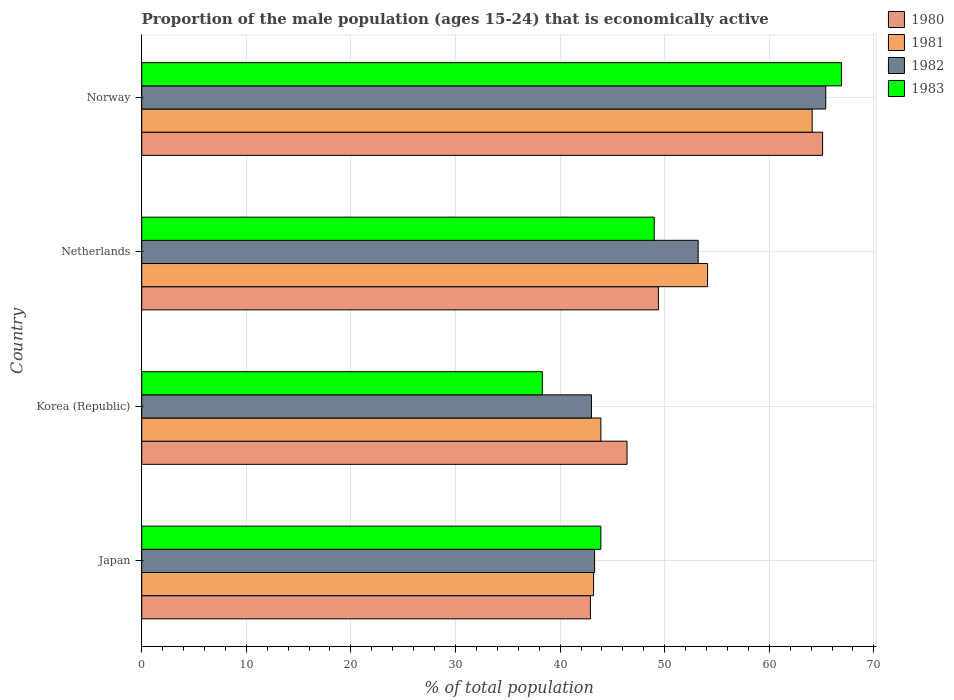How many different coloured bars are there?
Give a very brief answer. 4. How many groups of bars are there?
Give a very brief answer. 4. Are the number of bars on each tick of the Y-axis equal?
Ensure brevity in your answer.  Yes. How many bars are there on the 2nd tick from the top?
Ensure brevity in your answer.  4. What is the label of the 2nd group of bars from the top?
Your answer should be compact. Netherlands. In how many cases, is the number of bars for a given country not equal to the number of legend labels?
Offer a very short reply. 0. What is the proportion of the male population that is economically active in 1982 in Norway?
Your answer should be compact. 65.4. Across all countries, what is the maximum proportion of the male population that is economically active in 1981?
Provide a succinct answer. 64.1. Across all countries, what is the minimum proportion of the male population that is economically active in 1983?
Offer a very short reply. 38.3. In which country was the proportion of the male population that is economically active in 1981 maximum?
Your answer should be compact. Norway. In which country was the proportion of the male population that is economically active in 1982 minimum?
Give a very brief answer. Korea (Republic). What is the total proportion of the male population that is economically active in 1982 in the graph?
Offer a terse response. 204.9. What is the difference between the proportion of the male population that is economically active in 1982 in Netherlands and that in Norway?
Make the answer very short. -12.2. What is the difference between the proportion of the male population that is economically active in 1983 in Japan and the proportion of the male population that is economically active in 1980 in Norway?
Offer a terse response. -21.2. What is the average proportion of the male population that is economically active in 1982 per country?
Your answer should be very brief. 51.23. What is the difference between the proportion of the male population that is economically active in 1981 and proportion of the male population that is economically active in 1980 in Japan?
Offer a terse response. 0.3. What is the ratio of the proportion of the male population that is economically active in 1981 in Japan to that in Norway?
Provide a short and direct response. 0.67. What is the difference between the highest and the second highest proportion of the male population that is economically active in 1981?
Provide a short and direct response. 10. What is the difference between the highest and the lowest proportion of the male population that is economically active in 1981?
Offer a terse response. 20.9. Is the sum of the proportion of the male population that is economically active in 1980 in Japan and Korea (Republic) greater than the maximum proportion of the male population that is economically active in 1983 across all countries?
Give a very brief answer. Yes. What does the 1st bar from the bottom in Norway represents?
Your answer should be very brief. 1980. Is it the case that in every country, the sum of the proportion of the male population that is economically active in 1980 and proportion of the male population that is economically active in 1982 is greater than the proportion of the male population that is economically active in 1981?
Provide a short and direct response. Yes. Are all the bars in the graph horizontal?
Offer a terse response. Yes. Does the graph contain grids?
Your response must be concise. Yes. Where does the legend appear in the graph?
Keep it short and to the point. Top right. How many legend labels are there?
Offer a terse response. 4. How are the legend labels stacked?
Provide a succinct answer. Vertical. What is the title of the graph?
Make the answer very short. Proportion of the male population (ages 15-24) that is economically active. Does "2004" appear as one of the legend labels in the graph?
Provide a short and direct response. No. What is the label or title of the X-axis?
Keep it short and to the point. % of total population. What is the % of total population in 1980 in Japan?
Offer a very short reply. 42.9. What is the % of total population of 1981 in Japan?
Give a very brief answer. 43.2. What is the % of total population of 1982 in Japan?
Provide a succinct answer. 43.3. What is the % of total population in 1983 in Japan?
Provide a succinct answer. 43.9. What is the % of total population in 1980 in Korea (Republic)?
Your answer should be compact. 46.4. What is the % of total population of 1981 in Korea (Republic)?
Offer a very short reply. 43.9. What is the % of total population in 1982 in Korea (Republic)?
Provide a short and direct response. 43. What is the % of total population of 1983 in Korea (Republic)?
Make the answer very short. 38.3. What is the % of total population of 1980 in Netherlands?
Make the answer very short. 49.4. What is the % of total population in 1981 in Netherlands?
Offer a very short reply. 54.1. What is the % of total population in 1982 in Netherlands?
Provide a succinct answer. 53.2. What is the % of total population of 1980 in Norway?
Your response must be concise. 65.1. What is the % of total population of 1981 in Norway?
Make the answer very short. 64.1. What is the % of total population of 1982 in Norway?
Offer a terse response. 65.4. What is the % of total population in 1983 in Norway?
Your answer should be very brief. 66.9. Across all countries, what is the maximum % of total population in 1980?
Keep it short and to the point. 65.1. Across all countries, what is the maximum % of total population in 1981?
Make the answer very short. 64.1. Across all countries, what is the maximum % of total population of 1982?
Offer a terse response. 65.4. Across all countries, what is the maximum % of total population of 1983?
Provide a succinct answer. 66.9. Across all countries, what is the minimum % of total population in 1980?
Offer a terse response. 42.9. Across all countries, what is the minimum % of total population of 1981?
Make the answer very short. 43.2. Across all countries, what is the minimum % of total population in 1983?
Ensure brevity in your answer.  38.3. What is the total % of total population in 1980 in the graph?
Your answer should be compact. 203.8. What is the total % of total population of 1981 in the graph?
Your answer should be compact. 205.3. What is the total % of total population in 1982 in the graph?
Provide a succinct answer. 204.9. What is the total % of total population in 1983 in the graph?
Offer a terse response. 198.1. What is the difference between the % of total population of 1981 in Japan and that in Netherlands?
Make the answer very short. -10.9. What is the difference between the % of total population in 1980 in Japan and that in Norway?
Ensure brevity in your answer.  -22.2. What is the difference between the % of total population of 1981 in Japan and that in Norway?
Your answer should be very brief. -20.9. What is the difference between the % of total population in 1982 in Japan and that in Norway?
Provide a short and direct response. -22.1. What is the difference between the % of total population in 1981 in Korea (Republic) and that in Netherlands?
Provide a short and direct response. -10.2. What is the difference between the % of total population of 1982 in Korea (Republic) and that in Netherlands?
Your answer should be compact. -10.2. What is the difference between the % of total population in 1983 in Korea (Republic) and that in Netherlands?
Offer a very short reply. -10.7. What is the difference between the % of total population of 1980 in Korea (Republic) and that in Norway?
Offer a very short reply. -18.7. What is the difference between the % of total population in 1981 in Korea (Republic) and that in Norway?
Your answer should be very brief. -20.2. What is the difference between the % of total population of 1982 in Korea (Republic) and that in Norway?
Your answer should be compact. -22.4. What is the difference between the % of total population in 1983 in Korea (Republic) and that in Norway?
Offer a terse response. -28.6. What is the difference between the % of total population of 1980 in Netherlands and that in Norway?
Give a very brief answer. -15.7. What is the difference between the % of total population in 1981 in Netherlands and that in Norway?
Offer a terse response. -10. What is the difference between the % of total population in 1983 in Netherlands and that in Norway?
Your answer should be very brief. -17.9. What is the difference between the % of total population in 1980 in Japan and the % of total population in 1981 in Korea (Republic)?
Offer a terse response. -1. What is the difference between the % of total population of 1980 in Japan and the % of total population of 1982 in Korea (Republic)?
Provide a succinct answer. -0.1. What is the difference between the % of total population of 1981 in Japan and the % of total population of 1983 in Korea (Republic)?
Ensure brevity in your answer.  4.9. What is the difference between the % of total population of 1980 in Japan and the % of total population of 1983 in Netherlands?
Provide a succinct answer. -6.1. What is the difference between the % of total population of 1981 in Japan and the % of total population of 1982 in Netherlands?
Make the answer very short. -10. What is the difference between the % of total population of 1981 in Japan and the % of total population of 1983 in Netherlands?
Offer a very short reply. -5.8. What is the difference between the % of total population in 1982 in Japan and the % of total population in 1983 in Netherlands?
Keep it short and to the point. -5.7. What is the difference between the % of total population in 1980 in Japan and the % of total population in 1981 in Norway?
Keep it short and to the point. -21.2. What is the difference between the % of total population of 1980 in Japan and the % of total population of 1982 in Norway?
Your answer should be compact. -22.5. What is the difference between the % of total population of 1980 in Japan and the % of total population of 1983 in Norway?
Offer a very short reply. -24. What is the difference between the % of total population of 1981 in Japan and the % of total population of 1982 in Norway?
Offer a very short reply. -22.2. What is the difference between the % of total population of 1981 in Japan and the % of total population of 1983 in Norway?
Offer a terse response. -23.7. What is the difference between the % of total population of 1982 in Japan and the % of total population of 1983 in Norway?
Make the answer very short. -23.6. What is the difference between the % of total population in 1980 in Korea (Republic) and the % of total population in 1981 in Netherlands?
Your answer should be compact. -7.7. What is the difference between the % of total population in 1981 in Korea (Republic) and the % of total population in 1982 in Netherlands?
Your response must be concise. -9.3. What is the difference between the % of total population in 1981 in Korea (Republic) and the % of total population in 1983 in Netherlands?
Give a very brief answer. -5.1. What is the difference between the % of total population in 1982 in Korea (Republic) and the % of total population in 1983 in Netherlands?
Your answer should be compact. -6. What is the difference between the % of total population in 1980 in Korea (Republic) and the % of total population in 1981 in Norway?
Provide a short and direct response. -17.7. What is the difference between the % of total population of 1980 in Korea (Republic) and the % of total population of 1982 in Norway?
Your answer should be very brief. -19. What is the difference between the % of total population of 1980 in Korea (Republic) and the % of total population of 1983 in Norway?
Your answer should be compact. -20.5. What is the difference between the % of total population of 1981 in Korea (Republic) and the % of total population of 1982 in Norway?
Give a very brief answer. -21.5. What is the difference between the % of total population of 1981 in Korea (Republic) and the % of total population of 1983 in Norway?
Offer a terse response. -23. What is the difference between the % of total population of 1982 in Korea (Republic) and the % of total population of 1983 in Norway?
Offer a terse response. -23.9. What is the difference between the % of total population in 1980 in Netherlands and the % of total population in 1981 in Norway?
Ensure brevity in your answer.  -14.7. What is the difference between the % of total population of 1980 in Netherlands and the % of total population of 1982 in Norway?
Keep it short and to the point. -16. What is the difference between the % of total population in 1980 in Netherlands and the % of total population in 1983 in Norway?
Ensure brevity in your answer.  -17.5. What is the difference between the % of total population of 1982 in Netherlands and the % of total population of 1983 in Norway?
Provide a succinct answer. -13.7. What is the average % of total population of 1980 per country?
Your answer should be very brief. 50.95. What is the average % of total population of 1981 per country?
Offer a very short reply. 51.33. What is the average % of total population of 1982 per country?
Give a very brief answer. 51.23. What is the average % of total population in 1983 per country?
Your response must be concise. 49.52. What is the difference between the % of total population of 1980 and % of total population of 1981 in Japan?
Provide a short and direct response. -0.3. What is the difference between the % of total population in 1980 and % of total population in 1982 in Japan?
Your answer should be compact. -0.4. What is the difference between the % of total population of 1981 and % of total population of 1982 in Japan?
Provide a succinct answer. -0.1. What is the difference between the % of total population of 1980 and % of total population of 1982 in Korea (Republic)?
Provide a short and direct response. 3.4. What is the difference between the % of total population in 1981 and % of total population in 1982 in Korea (Republic)?
Provide a succinct answer. 0.9. What is the difference between the % of total population of 1982 and % of total population of 1983 in Korea (Republic)?
Give a very brief answer. 4.7. What is the difference between the % of total population of 1980 and % of total population of 1982 in Netherlands?
Offer a very short reply. -3.8. What is the difference between the % of total population of 1981 and % of total population of 1982 in Netherlands?
Your response must be concise. 0.9. What is the difference between the % of total population of 1982 and % of total population of 1983 in Netherlands?
Provide a succinct answer. 4.2. What is the difference between the % of total population in 1980 and % of total population in 1981 in Norway?
Offer a terse response. 1. What is the difference between the % of total population in 1980 and % of total population in 1983 in Norway?
Offer a very short reply. -1.8. What is the difference between the % of total population of 1981 and % of total population of 1982 in Norway?
Your response must be concise. -1.3. What is the difference between the % of total population in 1982 and % of total population in 1983 in Norway?
Your response must be concise. -1.5. What is the ratio of the % of total population in 1980 in Japan to that in Korea (Republic)?
Make the answer very short. 0.92. What is the ratio of the % of total population of 1981 in Japan to that in Korea (Republic)?
Keep it short and to the point. 0.98. What is the ratio of the % of total population in 1983 in Japan to that in Korea (Republic)?
Your answer should be very brief. 1.15. What is the ratio of the % of total population of 1980 in Japan to that in Netherlands?
Give a very brief answer. 0.87. What is the ratio of the % of total population in 1981 in Japan to that in Netherlands?
Offer a terse response. 0.8. What is the ratio of the % of total population in 1982 in Japan to that in Netherlands?
Provide a short and direct response. 0.81. What is the ratio of the % of total population of 1983 in Japan to that in Netherlands?
Ensure brevity in your answer.  0.9. What is the ratio of the % of total population of 1980 in Japan to that in Norway?
Ensure brevity in your answer.  0.66. What is the ratio of the % of total population in 1981 in Japan to that in Norway?
Your response must be concise. 0.67. What is the ratio of the % of total population of 1982 in Japan to that in Norway?
Your answer should be very brief. 0.66. What is the ratio of the % of total population of 1983 in Japan to that in Norway?
Ensure brevity in your answer.  0.66. What is the ratio of the % of total population in 1980 in Korea (Republic) to that in Netherlands?
Provide a succinct answer. 0.94. What is the ratio of the % of total population in 1981 in Korea (Republic) to that in Netherlands?
Keep it short and to the point. 0.81. What is the ratio of the % of total population of 1982 in Korea (Republic) to that in Netherlands?
Offer a terse response. 0.81. What is the ratio of the % of total population of 1983 in Korea (Republic) to that in Netherlands?
Your answer should be very brief. 0.78. What is the ratio of the % of total population in 1980 in Korea (Republic) to that in Norway?
Provide a short and direct response. 0.71. What is the ratio of the % of total population of 1981 in Korea (Republic) to that in Norway?
Offer a terse response. 0.68. What is the ratio of the % of total population of 1982 in Korea (Republic) to that in Norway?
Provide a short and direct response. 0.66. What is the ratio of the % of total population of 1983 in Korea (Republic) to that in Norway?
Offer a very short reply. 0.57. What is the ratio of the % of total population in 1980 in Netherlands to that in Norway?
Your answer should be compact. 0.76. What is the ratio of the % of total population in 1981 in Netherlands to that in Norway?
Give a very brief answer. 0.84. What is the ratio of the % of total population of 1982 in Netherlands to that in Norway?
Offer a very short reply. 0.81. What is the ratio of the % of total population of 1983 in Netherlands to that in Norway?
Your answer should be very brief. 0.73. What is the difference between the highest and the second highest % of total population of 1981?
Provide a succinct answer. 10. What is the difference between the highest and the lowest % of total population of 1981?
Provide a short and direct response. 20.9. What is the difference between the highest and the lowest % of total population in 1982?
Your answer should be very brief. 22.4. What is the difference between the highest and the lowest % of total population in 1983?
Offer a terse response. 28.6. 